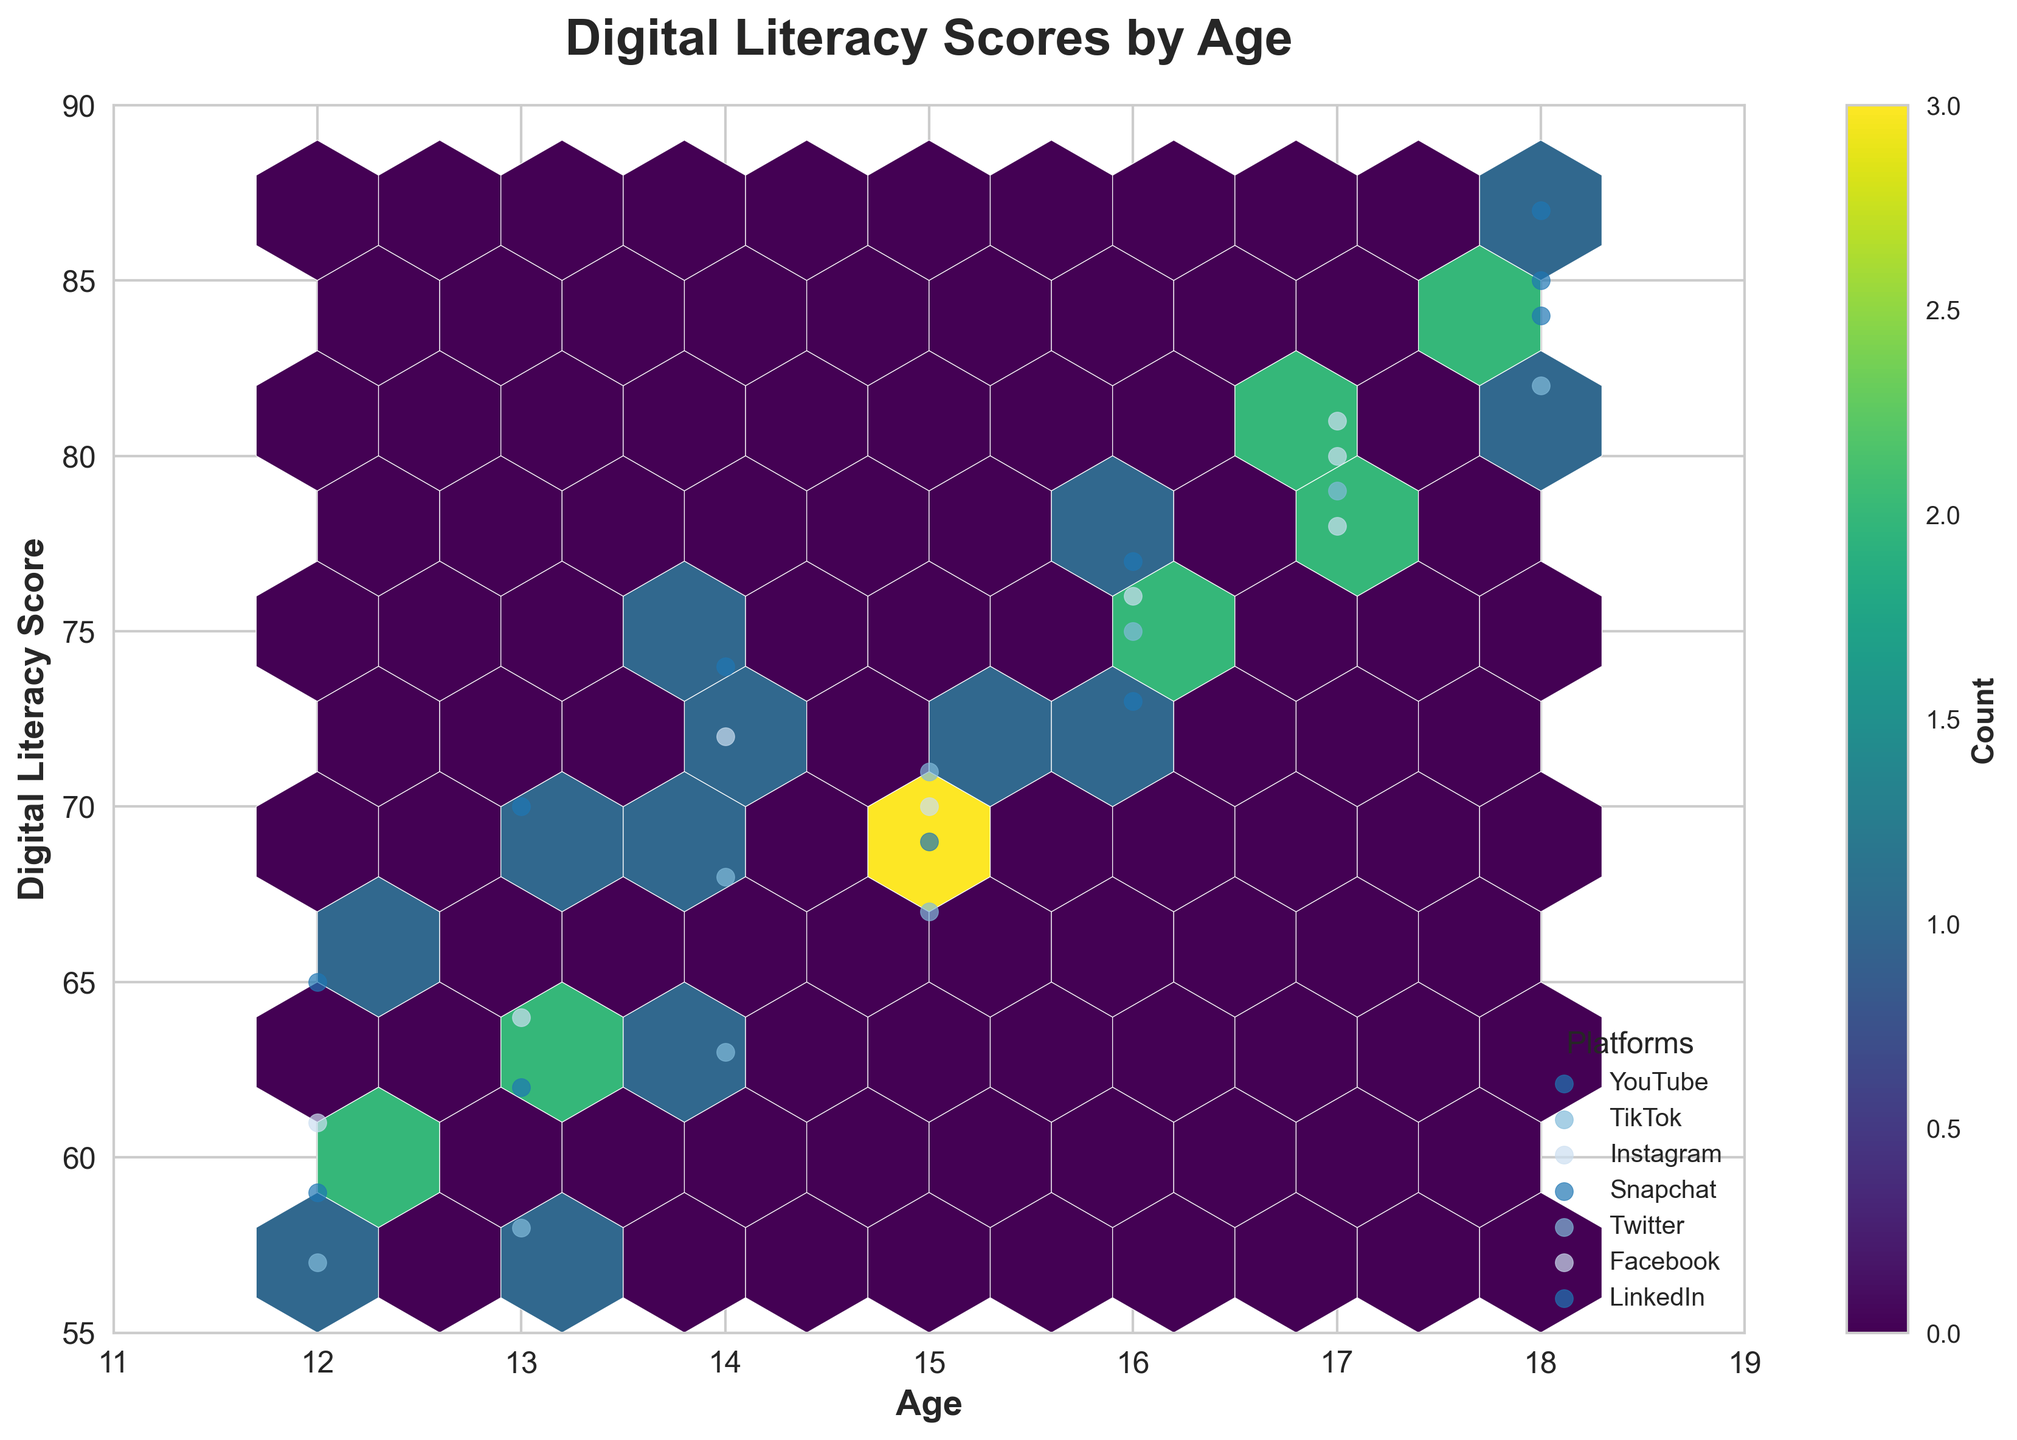What is the title of the hexbin plot? The title of the plot is usually found at the top and describes the main purpose or dataset of the visualization. In this case, the title reads "Digital Literacy Scores by Age".
Answer: Digital Literacy Scores by Age What are the x and y axes labels? The labels for the x and y axes provide information about what data is represented on each axis. The x-axis is labeled 'Age', and the y-axis is labeled 'Digital Literacy Score'.
Answer: Age, Digital Literacy Score What age range is covered in the plot? To determine the age range, look at the limits set on the x-axis. Here, the x-axis ranges from 11 to 19 years old.
Answer: 11 to 19 years old Which age group has the highest digital literacy scores? By looking at the plot, identify the points with the highest y-axis values. Ages 18 and 17 appear to have the highest digital literacy scores.
Answer: Ages 18 and 17 Which platform has the most data points in the plot? Count the scatter points associated with each platform label within the hexbin plot to determine frequency. Here, YouTube appears to have the most data points.
Answer: YouTube At what age is the digital literacy score most widely spread across different platforms? Check for the age with the widest range of y-axis values (Digital Literacy Scores) represented by multiple platforms. Age 18 shows a broad spread across different platforms.
Answer: Age 18 What is the general trend in digital literacy scores as students grow older? Observe the distribution of hexbin points from younger to older ages. There appears to be an upward trend, with older students generally having higher digital literacy scores.
Answer: Increasing How does the digital literacy score for Facebook compare to other platforms at age 17? At age 17, find the digital literacy scores for all marked platforms and compare them. Facebook shows one of the highest scores.
Answer: Higher What is the count of data points that fall within the hexbin cell located at age 15 and a digital literacy score of around 70 from the colorbar? Use the color intensity of the specified hexbin to refer to the count value on the colorbar legend. The color around age 15 with a score of 70 suggests a count value.
Answer: Approximate count as per color intensity How do the digital literacy scores for Twitter vary across ages? Compare digital literacy scores for the points marked as Twitter across different ages to see if there's an upward, downward, or stable trend. Twitter's scores generally increase with age.
Answer: Increasing 